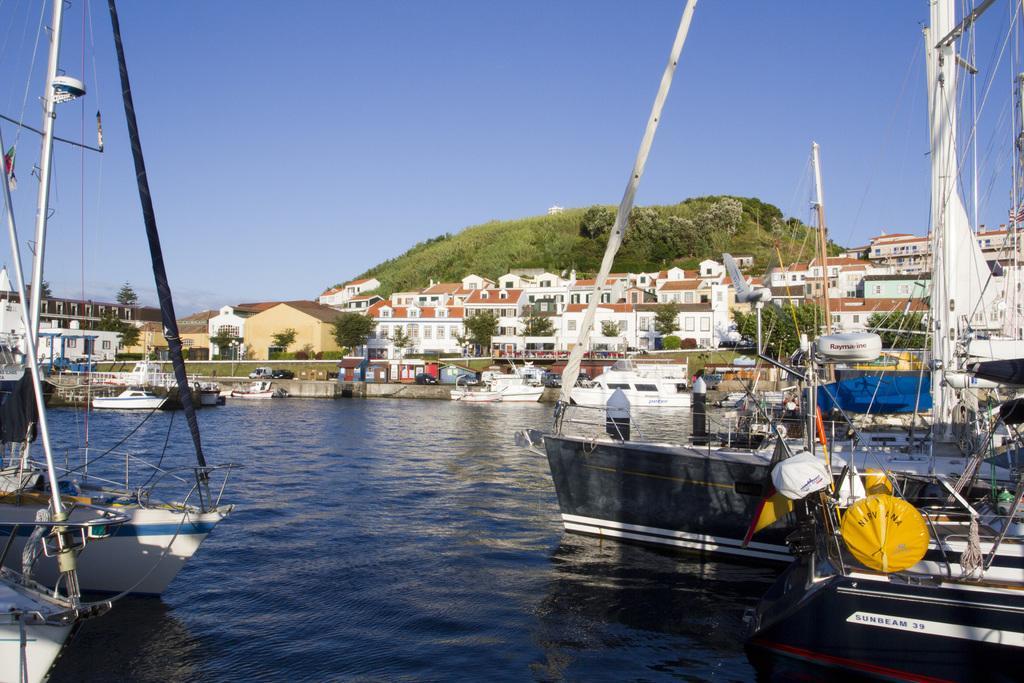In one or two sentences, can you explain what this image depicts? There are boats on the water. In the background, there are trees, buildings which are having glass windows, mountain and there is blue sky. 